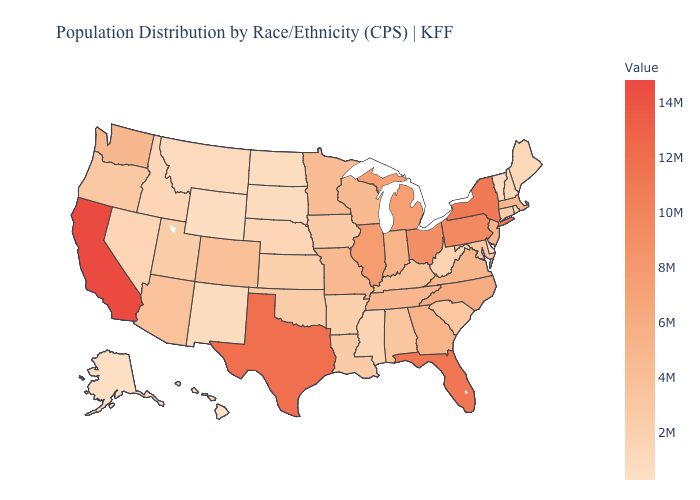Which states have the lowest value in the USA?
Write a very short answer. Hawaii. Among the states that border Florida , which have the highest value?
Give a very brief answer. Georgia. Does the map have missing data?
Be succinct. No. Among the states that border Indiana , which have the lowest value?
Give a very brief answer. Kentucky. Does Arizona have a lower value than Georgia?
Short answer required. Yes. Does California have the highest value in the USA?
Write a very short answer. Yes. Which states have the highest value in the USA?
Concise answer only. California. Among the states that border Vermont , does New York have the lowest value?
Quick response, please. No. 